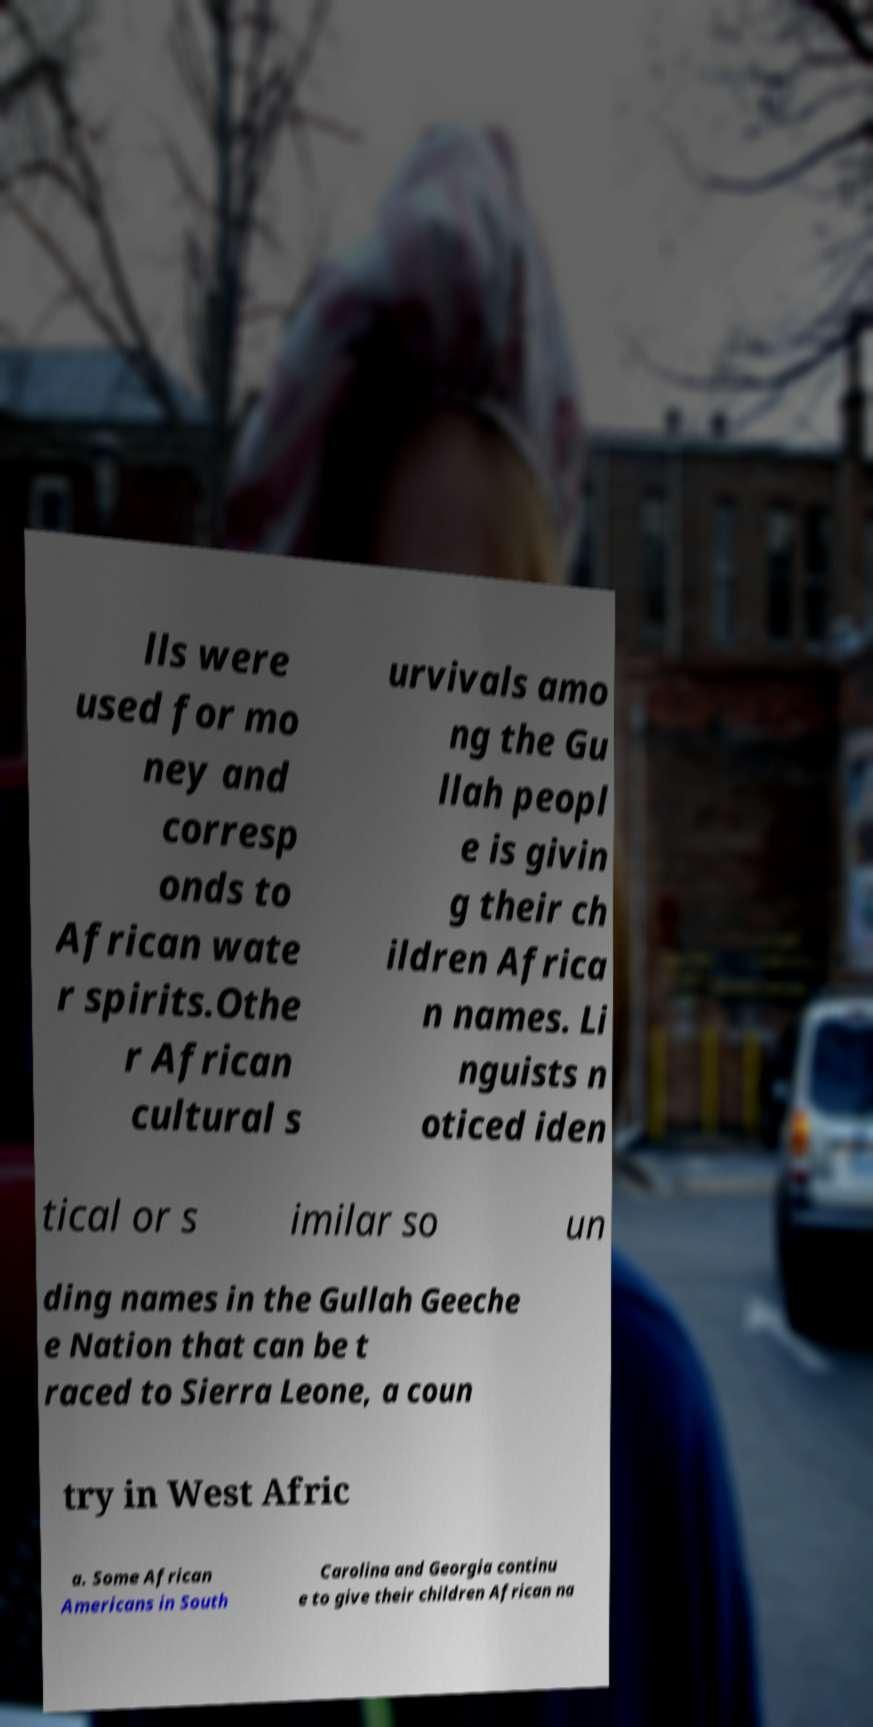For documentation purposes, I need the text within this image transcribed. Could you provide that? lls were used for mo ney and corresp onds to African wate r spirits.Othe r African cultural s urvivals amo ng the Gu llah peopl e is givin g their ch ildren Africa n names. Li nguists n oticed iden tical or s imilar so un ding names in the Gullah Geeche e Nation that can be t raced to Sierra Leone, a coun try in West Afric a. Some African Americans in South Carolina and Georgia continu e to give their children African na 